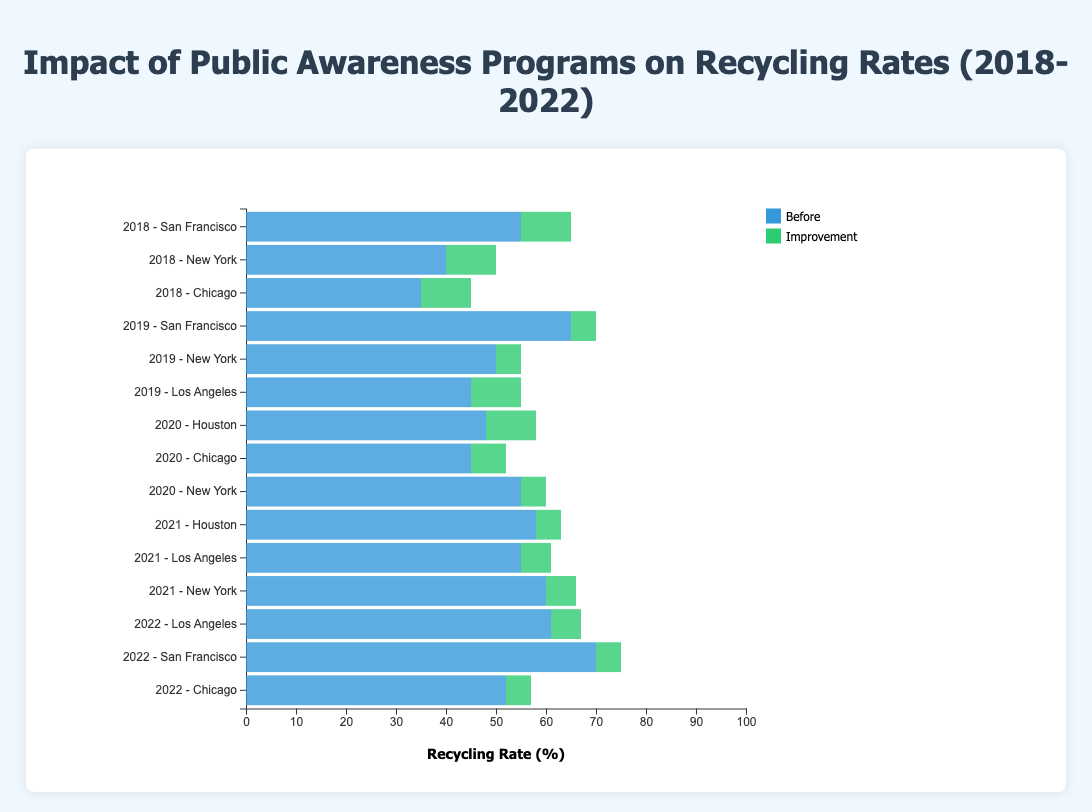What was the recycling rate improvement for the "School Education Campaign" in New York in 2021? The figure shows a recycling rate before the program of 60% and after the program of 66%. The improvement is 66% - 60%, which equals 6%.
Answer: 6% Which program showed the most significant improvement in the recycling rate in 2018? The figure displays the recycling rate improvements for different programs in 2018. The "Community Recycling Workshops" in San Francisco improved from 55% to 65%, the "School Education Campaign" in New York improved from 40% to 50%, and the "Media Outreach Initiative" in Chicago improved from 35% to 45%. The "Community Recycling Workshops" had the highest improvement of 10%.
Answer: Community Recycling Workshops Between 2019 and 2022, which year had the highest initial (before) recycling rate? Check each year's data for the initial recycling rate. For 2019, San Francisco had 65%, New York had 50%, and Los Angeles had 45%. For 2020, Houston had 48%, Chicago had 45%, and New York had 55%. For 2021, Houston had 58%, Los Angeles had 55%, and New York had 60%. For 2022, Los Angeles had 61%, San Francisco had 70%, and Chicago had 52%. The highest initial rate is 70% in 2022 (San Francisco).
Answer: 2022 Which city had the smallest increase in recycling rate in 2020? Review the improvements in 2020: Houston's "Neighborhood Clean-up Events" improved from 48% to 58%, Chicago's "Media Outreach Initiative" improved from 45% to 52%, and New York's "School Education Campaign" improved from 55% to 60%. The smallest increase was in Chicago with a 7% improvement.
Answer: Chicago How did the "Social Media Challenge" impact the recycling rate in Los Angeles from 2019 to 2022? In 2019, the "Social Media Challenge" had an initial rate of 45% and a final rate of 55%. In 2021, it had an initial rate of 55% and a final rate of 61%. In 2022, it had an initial rate of 61% and a final rate of 67%. The improvements for each period are 10%, 6%, and 6%, respectively.
Answer: Improvement of 10% (2019), 6% (2021), 6% (2022) Which program and year saw a recycling rate improvement from below 50% to above 60%? Look for programs where the rate increased from below 50% to above 60%. In 2018, the "School Education Campaign" in New York moved from 40% to 50% (not above 60%). No programs in 2019 apply. In 2020, no program fits. In 2021, the "School Education Campaign" in New York increased from 60% (already above). In 2022, no programs fit. The answer is none; no program improved from below 50% to above 60% directly.
Answer: None Which city had the highest recycling rate after participating in a public awareness program in 2018? Check the final recycling rates for cities in 2018: San Francisco (65%), New York (50%), Chicago (45%). The highest final rate was in San Francisco.
Answer: San Francisco What was the overall trend in the recycling rate in New York from 2018 to 2021? Follow the trend in recycling rates: 2018 (40% to 50%), 2019 (50% to 55%), 2020 (55% to 60%), and 2021 (60% to 66%). The trend in New York shows a continuous yearly improvement.
Answer: Continuous improvement Which year's "Community Recycling Workshops" achieved the highest improvement in San Francisco? The recycling rates for "Community Recycling Workshops" in San Francisco were 55% to 65% in 2018 (10%), 65% to 70% in 2019 (5%), and 70% to 75% in 2022 (5%). The highest improvement was in 2018.
Answer: 2018 In which city and year did a public awareness program result in the lowest post-program recycling rate? Check post-program rates: San Francisco (65%, 70%, 75%), New York (50%, 55%, 60%, 66%), Chicago (45%, 52%, 57%), Los Angeles (55%, 61%, 67%), Houston (58%, 63%). The lowest post-program rate is Chicago in 2018 (45%).
Answer: Chicago, 2018 